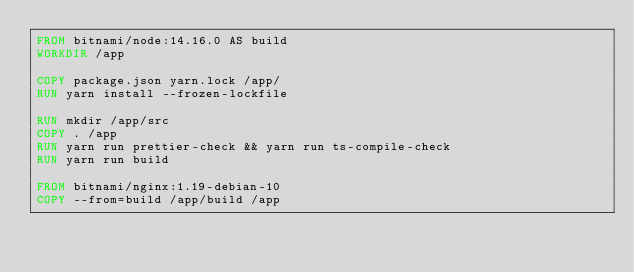Convert code to text. <code><loc_0><loc_0><loc_500><loc_500><_Dockerfile_>FROM bitnami/node:14.16.0 AS build
WORKDIR /app

COPY package.json yarn.lock /app/
RUN yarn install --frozen-lockfile

RUN mkdir /app/src
COPY . /app
RUN yarn run prettier-check && yarn run ts-compile-check
RUN yarn run build

FROM bitnami/nginx:1.19-debian-10
COPY --from=build /app/build /app
</code> 